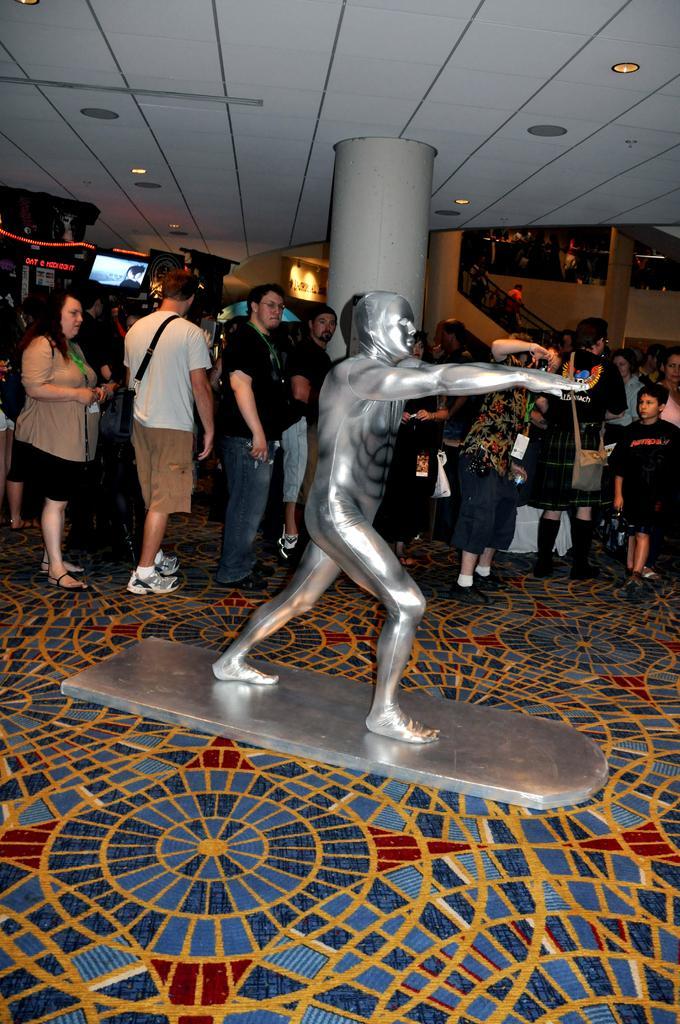Describe this image in one or two sentences. In the middle of the image there is a statue. Behind the statue few people are standing and watching. At the top of the image there is roof and lights. 